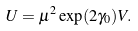<formula> <loc_0><loc_0><loc_500><loc_500>U = \mu ^ { 2 } \exp ( 2 \gamma _ { 0 } ) V .</formula> 